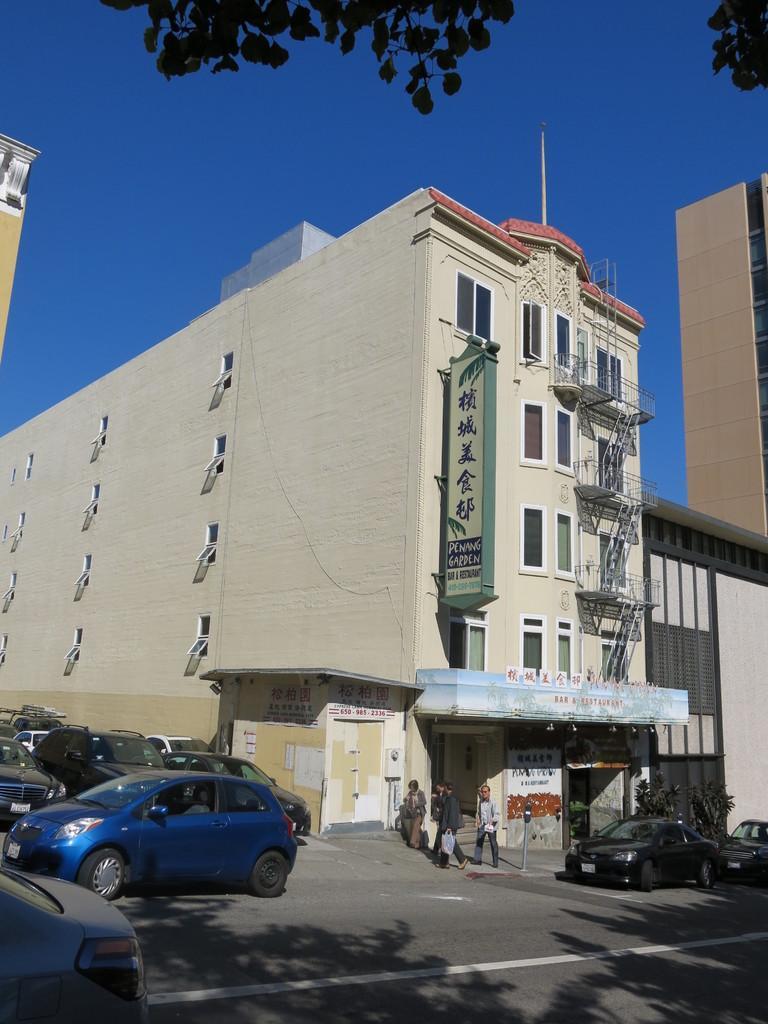Please provide a concise description of this image. In this image, we can see buildings, walls, windows, stairs, hoardings, posters and plants. At the bottom of the image, we can see few vehicles, road and people. Background there is a sky. Here we can see a pole and tree leaves. 